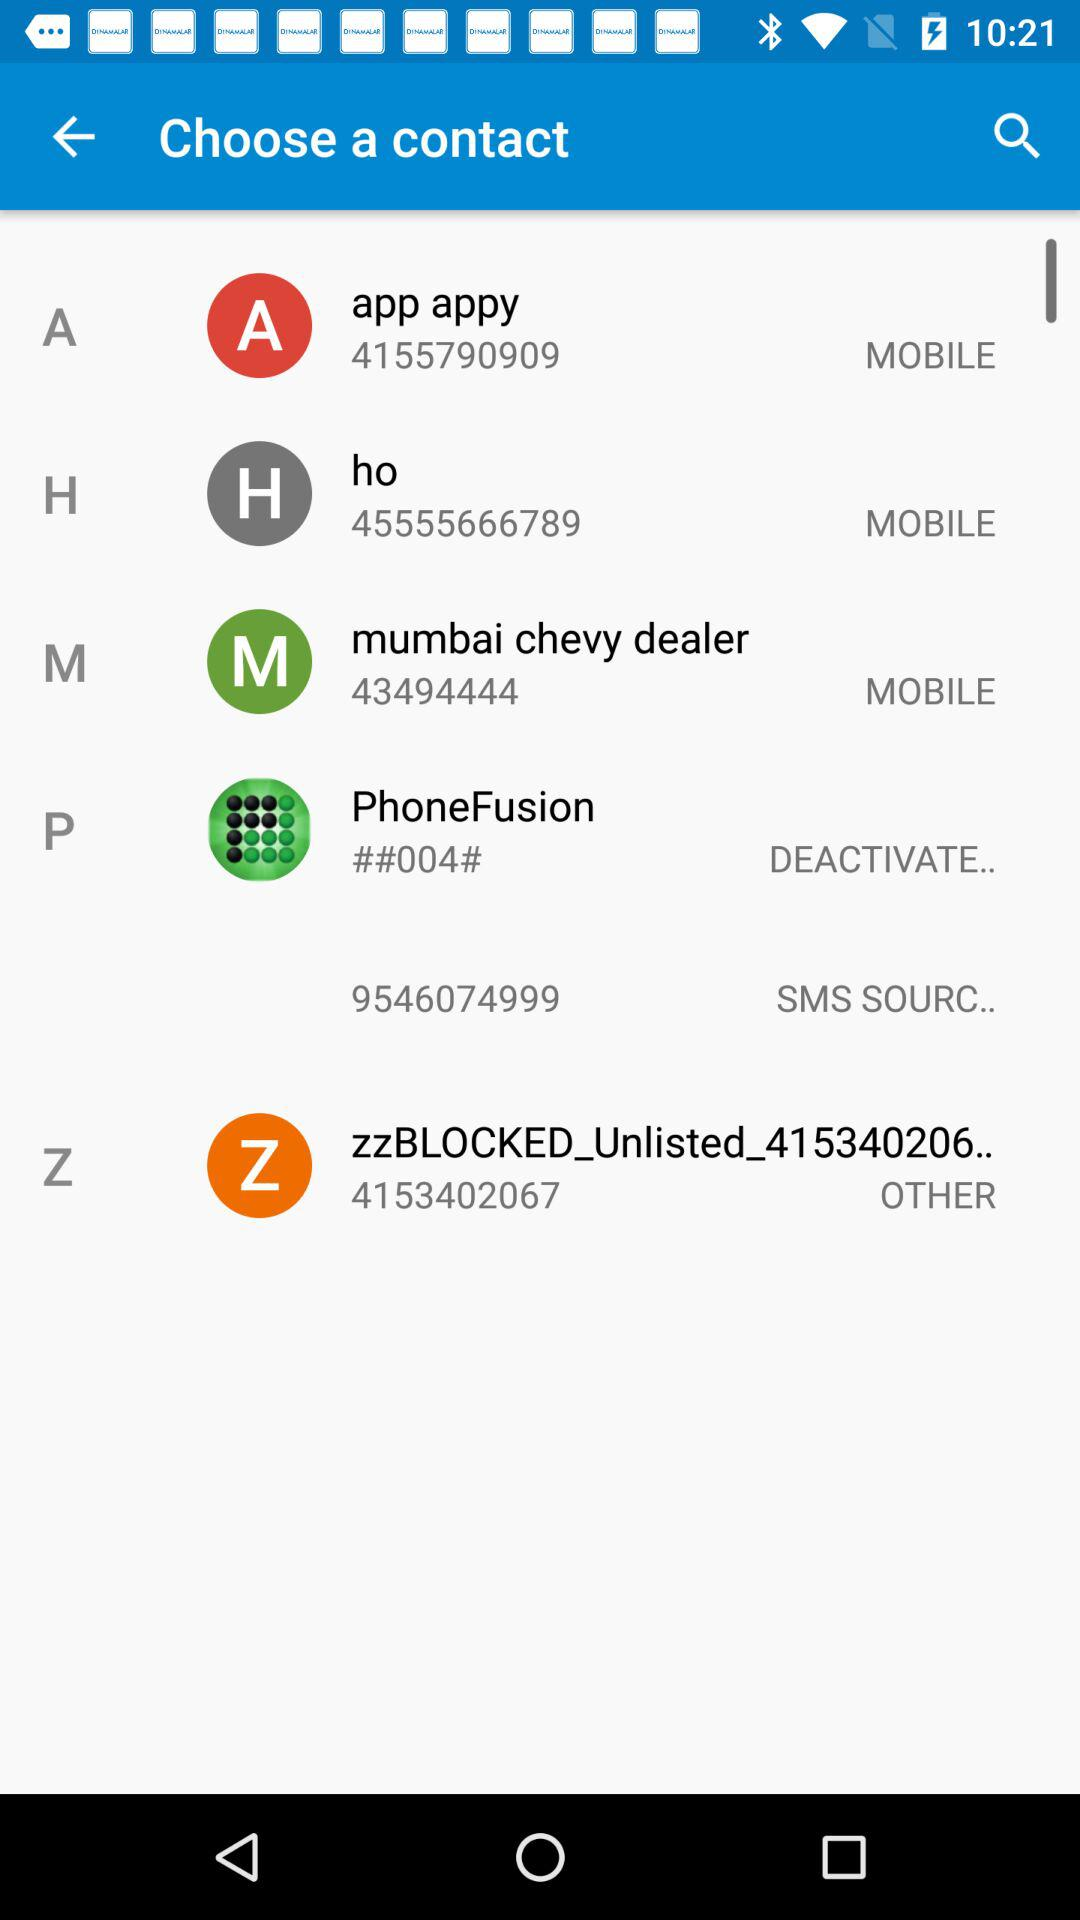What is the contact number of "ho"? The contact number of "ho" is 45555666789. 